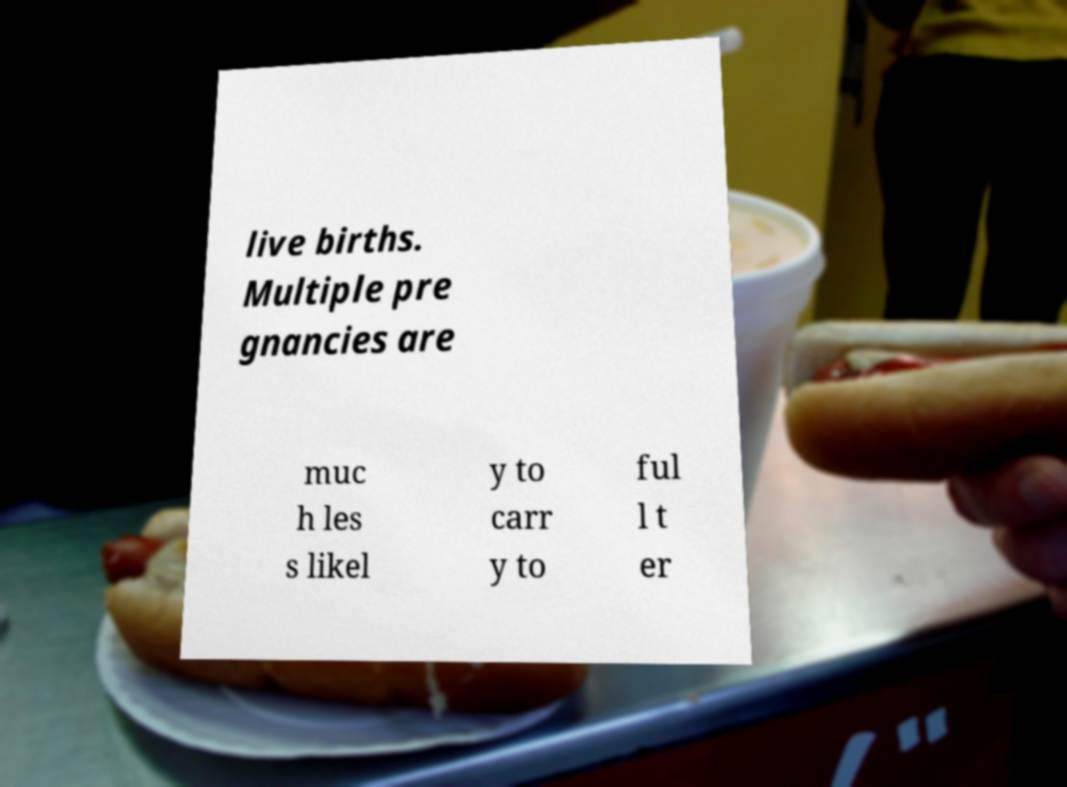Please identify and transcribe the text found in this image. live births. Multiple pre gnancies are muc h les s likel y to carr y to ful l t er 